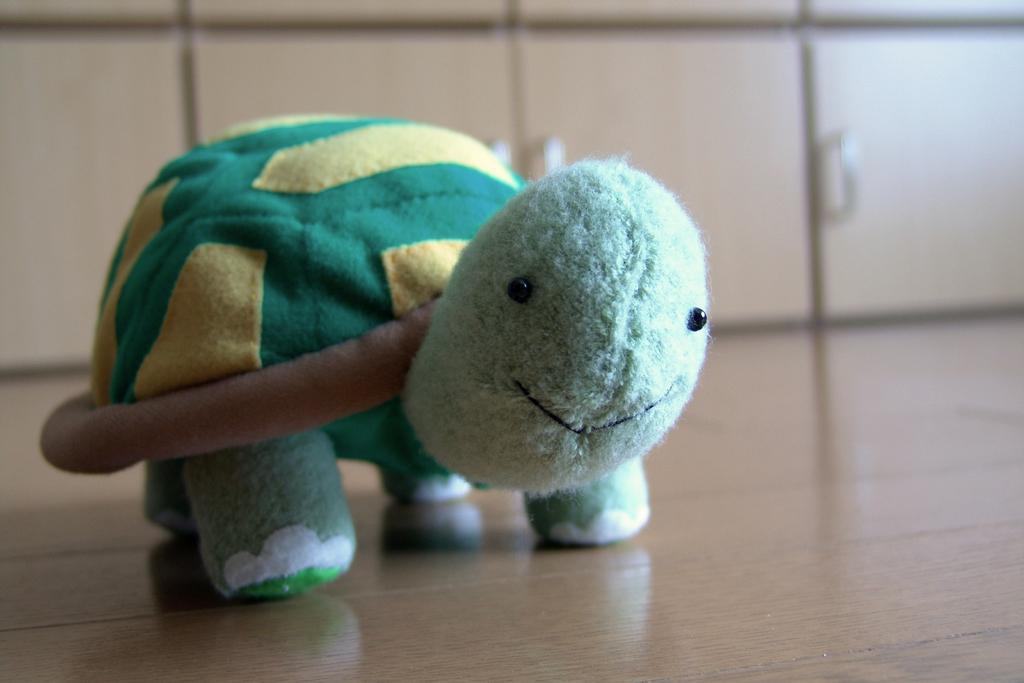Can you describe this image briefly? In this image I can see a doll in the middle, it is in green color. 